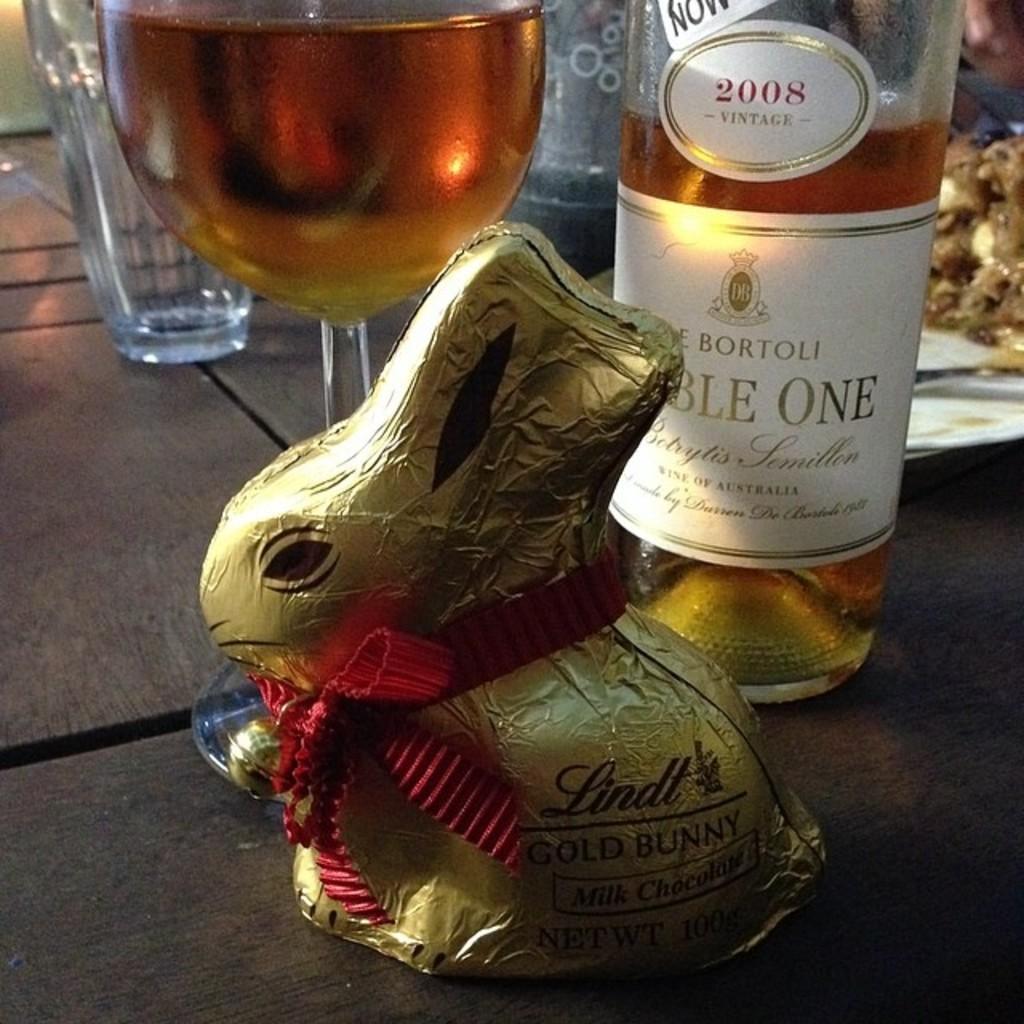Please provide a concise description of this image. There is a table which has a wine bottle and a glass of wine,a chocolate and some eatables on it. 